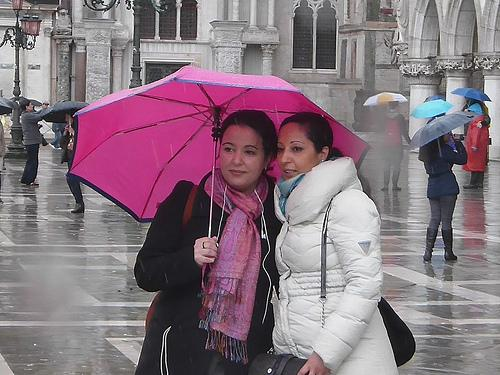What is the sentiment of the scene in the image? The sentiment is a mixture of dreariness due to the rain and companionship from people sharing umbrellas. Identify any water-related elements in the image. Raindrops splashing on the sidewalk, and people using umbrellas to shield themselves from the rain. Give a brief description of the woman wearing a pink scarf. The woman is wearing a black coat and a pink paisley scarf with fringe around her neck. What is the person in the red raincoat doing? The person wearing a red raincoat is standing in the rain, seemingly walking on the sidewalk. How many umbrellas can be seen in the image, and what colors are they? There are six umbrellas: pink with purple trim, white and yellow, bright blue, light bright blue, white and gold color, and dark blue. Mention any footwear present in the image. Black boots worn by a woman in a dark blue coat and black rain boots worn by another woman. Provide a summary of the scene depicted in the image. Pedestrians with umbrellas in the rain, including two women sharing a pink umbrella, a woman in a white coat, a man in a red raincoat, and others with different colored umbrellas. Identify the objects being held by individuals in the image. Umbrellas, a black purse, a ring on a hand, a red backpack, and a camera. Is there any architectural detail mentioned in the image? If so, describe it. Yes, there's an ornate cement column on a building and a fancy double window on a big building. Describe the interaction between two women under the same umbrella. Two women are standing close together, sharing a pink umbrella with blue trim to protect themselves from the rain. 